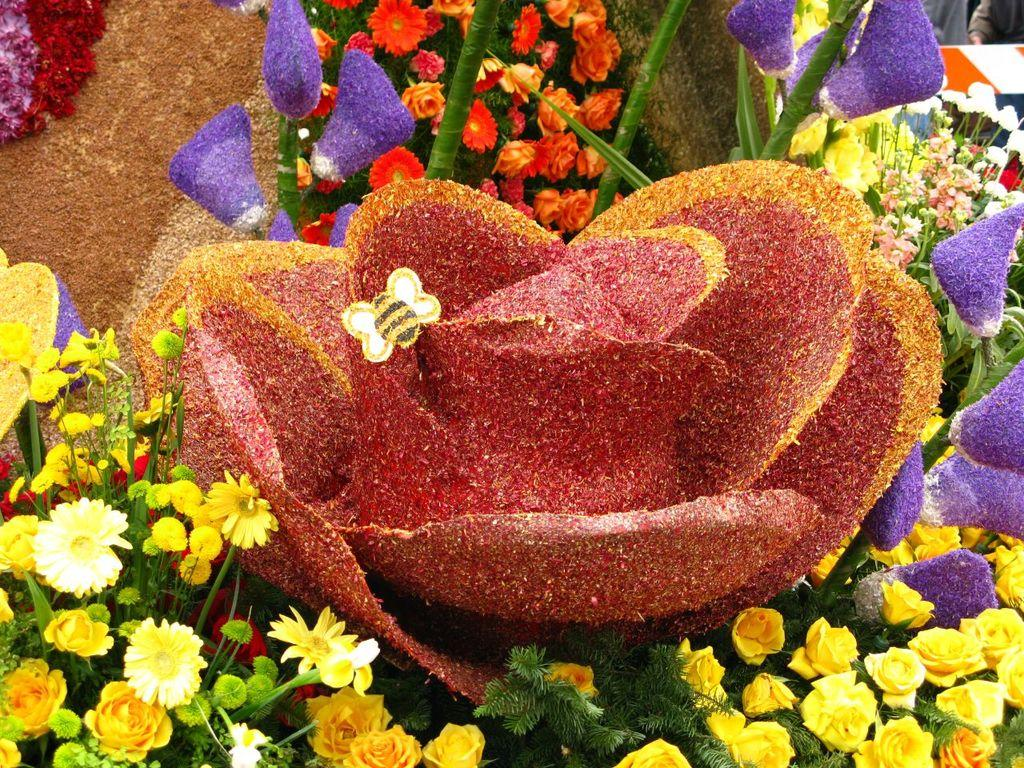What type of plants can be seen in the image? There are many colorful flowers in the image. Can you describe the colors of the flowers? The flowers in the image have various colors. What might be the purpose of having these flowers in the image? The flowers may be used for decoration or to add visual interest to the scene. What is there is a song playing in the background of the image? There is no mention of a song or any audio in the image, so it cannot be determined if there is a song playing in the background. 